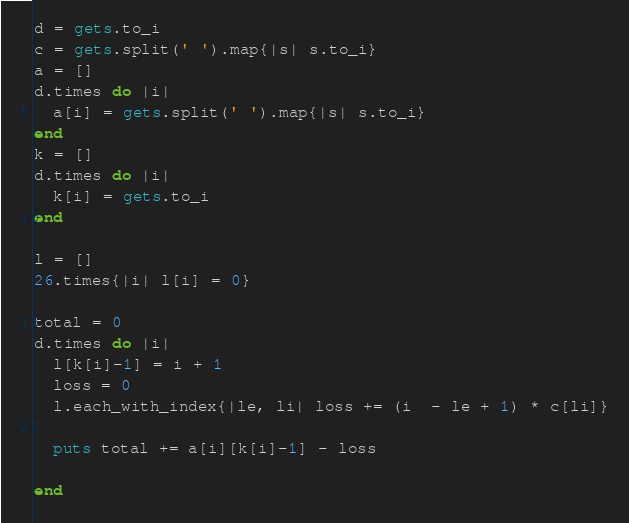Convert code to text. <code><loc_0><loc_0><loc_500><loc_500><_Ruby_>d = gets.to_i
c = gets.split(' ').map{|s| s.to_i}
a = []
d.times do |i|
  a[i] = gets.split(' ').map{|s| s.to_i}
end
k = []
d.times do |i|
  k[i] = gets.to_i
end

l = []
26.times{|i| l[i] = 0}

total = 0
d.times do |i|
  l[k[i]-1] = i + 1
  loss = 0
  l.each_with_index{|le, li| loss += (i  - le + 1) * c[li]}
    
  puts total += a[i][k[i]-1] - loss
 
end</code> 